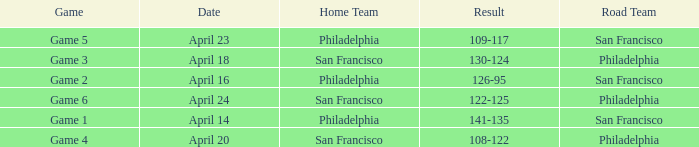Which game had a result of 126-95? Game 2. 